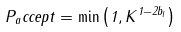Convert formula to latex. <formula><loc_0><loc_0><loc_500><loc_500>P _ { a } c c e p t = \min \left ( 1 , K ^ { 1 - 2 b _ { l } } \right )</formula> 